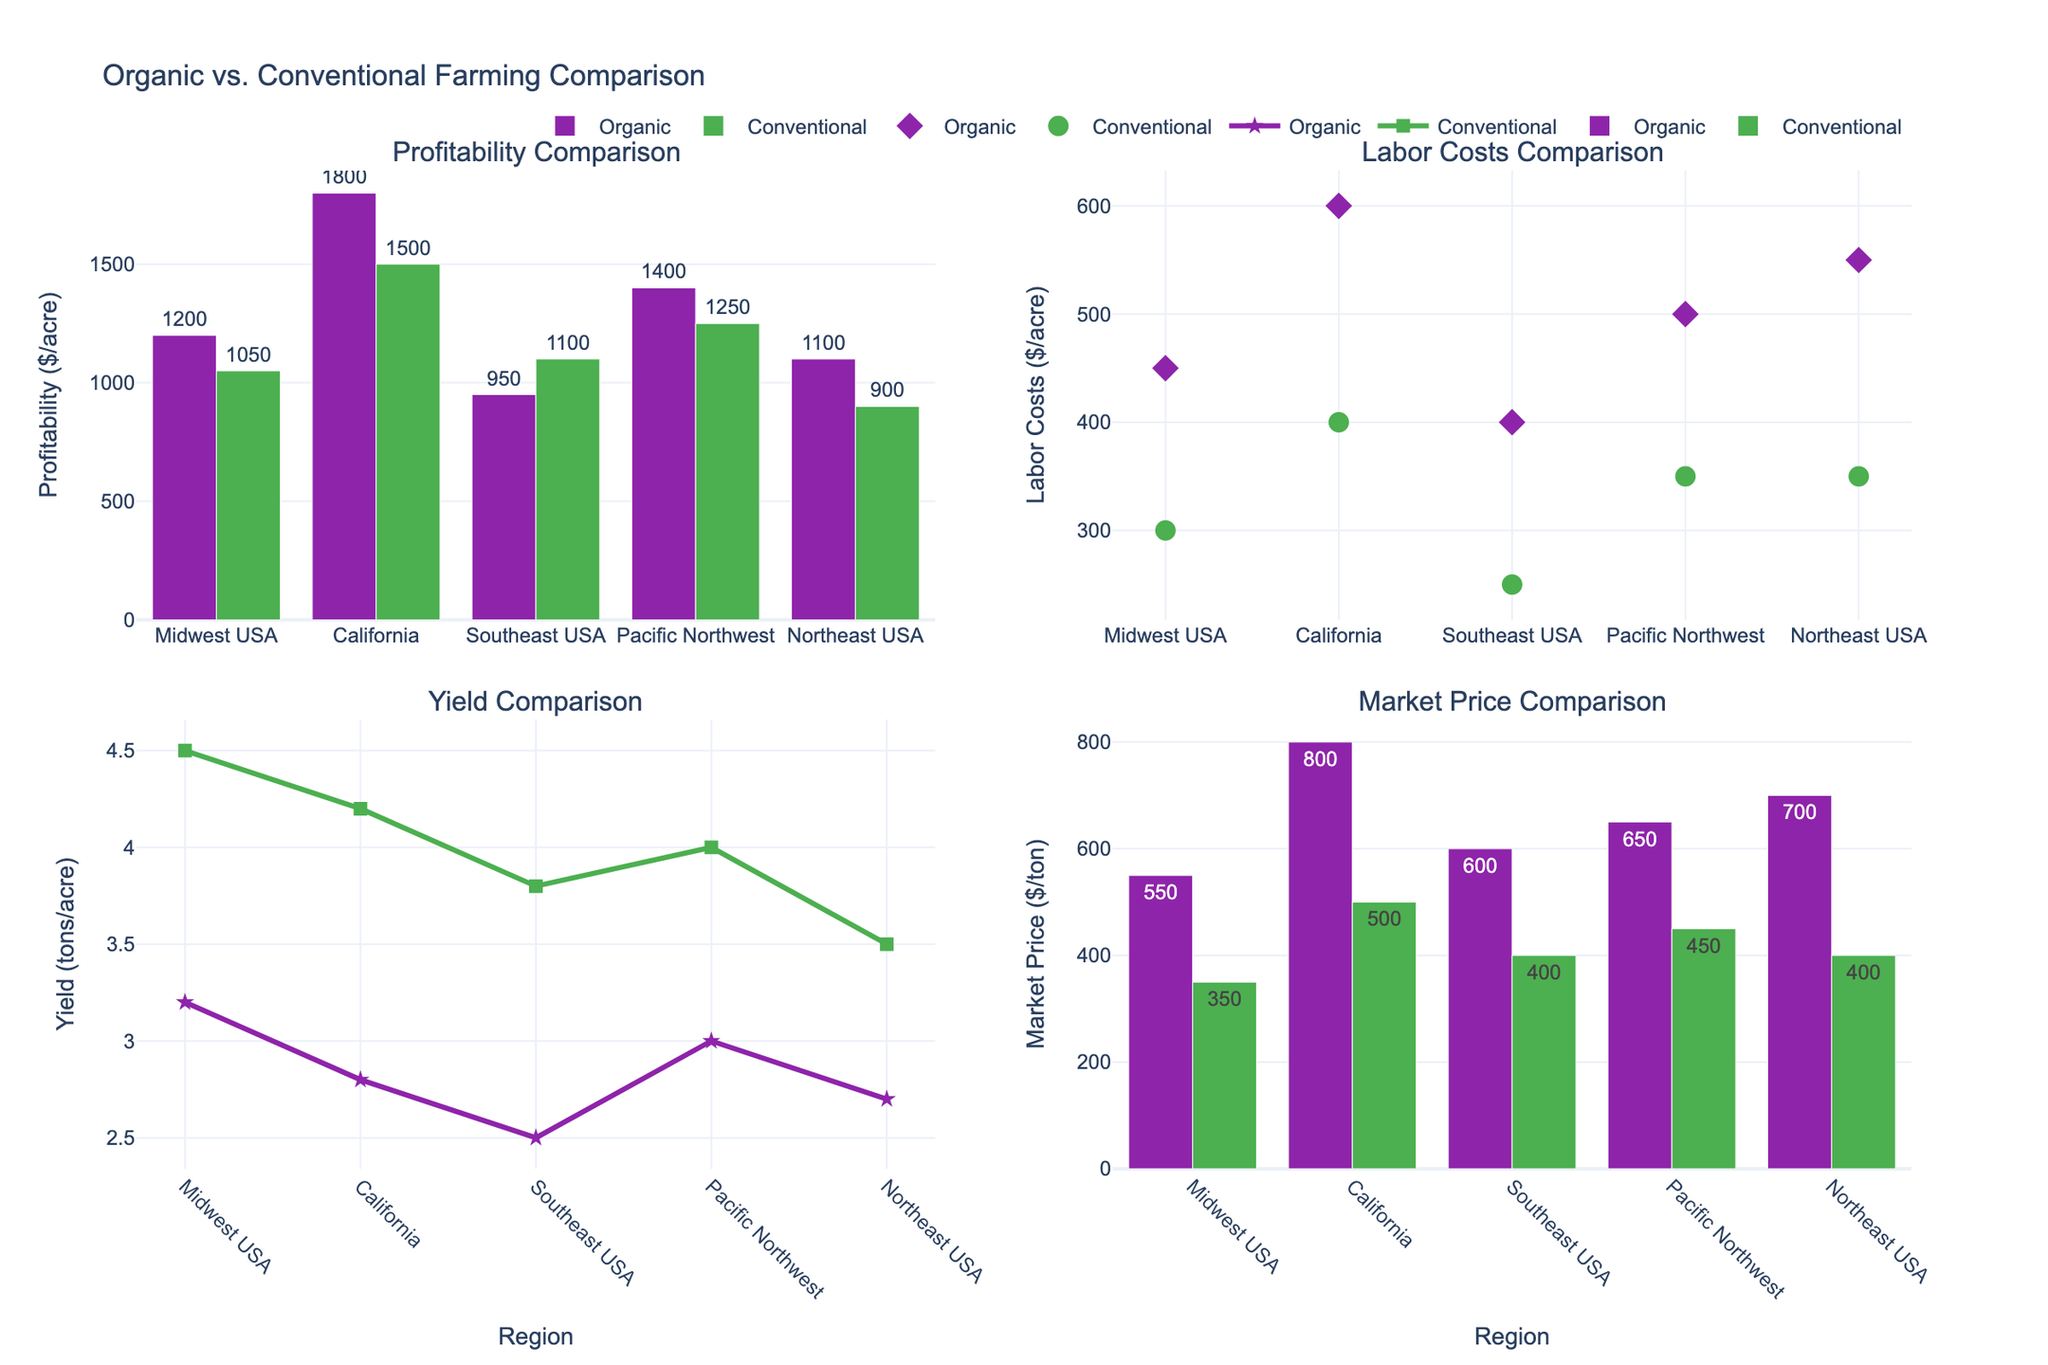What is the title of the figure? The title of the figure is clearly shown at the top of the plot. By looking at the rendered figure, we can see the text used for the title.
Answer: "Organic vs. Conventional Farming Comparison" How many regions are compared in the figure? The x-axes of all subplots list the regions being compared. Counting the unique entries provides the number of regions.
Answer: 5 Which region has the highest profitability for organic farming? By observing the bar heights for organic farming in the "Profitability Comparison" subplot (top-left), the highest bar indicates the region with the highest profitability.
Answer: California Which farming type has the higher market price in the Northeast USA? Looking at the "Market Price Comparison" subplot (bottom-right) and comparing the bars for the Northeast USA, the taller bar represents the higher market price.
Answer: Organic What is the average profitability for Organic farming across all regions? Sum the profitability values for Organic farming from the "Profitability Comparison" subplot and divide by the number of regions. The values are 1200, 1800, 950, 1400, and 1100. Sum: 1200 + 1800 + 950 + 1400 + 1100 = 7450. Divide by 5 regions: 7450 / 5 = 1490.
Answer: 1490 Which farming type generally has lower labor costs across most regions? By comparing the scatter plot points in the "Labor Costs Comparison" subplot (top-right), observe which farming type (represented by different symbols) generally has lower values.
Answer: Conventional Is the yield higher for Organic or Conventional farming in the Midwest USA? Looking at the "Yield Comparison" subplot (bottom-left) for the Midwest USA, compare the line+marker heights for the two farming types.
Answer: Conventional What is the difference in market price between Organic and Conventional farming in the Pacific Northwest? From the "Market Price Comparison" subplot, subtract the market price for Conventional farming from that for Organic farming for the Pacific Northwest. Market price difference: 650 (Organic) - 450 (Conventional) = 200.
Answer: 200 Which farming type yields more tons per acre in California? In the "Yield Comparison" subplot, compare the height of the lines+markers for California for both farming types.
Answer: Conventional Is the profitability per acre generally higher or lower for Organic farming compared to Conventional farming? By examining the "Profitability Comparison" subplot, compare the heights of the bars for Organic farming versus Conventional farming across all regions.
Answer: Higher 